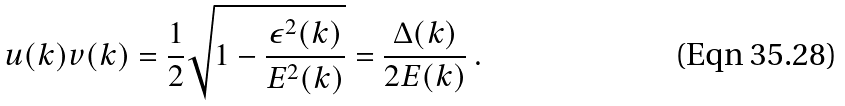Convert formula to latex. <formula><loc_0><loc_0><loc_500><loc_500>u ( k ) v ( k ) = \frac { 1 } { 2 } \sqrt { 1 - \frac { \epsilon ^ { 2 } ( k ) } { E ^ { 2 } ( k ) } } = \frac { \Delta ( k ) } { 2 E ( k ) } \ .</formula> 